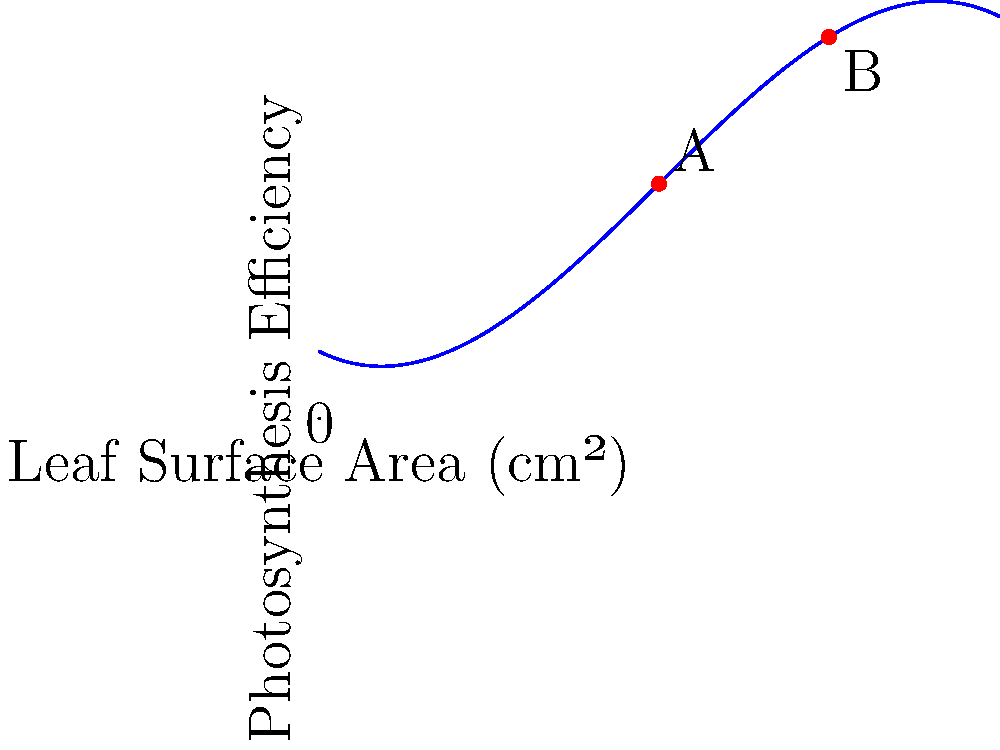The graph shows the relationship between leaf surface area and photosynthesis efficiency for a particular plant species. Point A represents a leaf with a surface area of 10 cm², and point B represents a leaf with a surface area of 15 cm². What is the approximate difference in photosynthesis efficiency between these two leaf sizes? To solve this problem, we need to follow these steps:

1. Identify the y-coordinates (photosynthesis efficiency) for points A and B:
   - Point A (10 cm²): y ≈ 3.5
   - Point B (15 cm²): y ≈ 4.2

2. Calculate the difference in photosynthesis efficiency:
   $\text{Difference} = \text{Efficiency at B} - \text{Efficiency at A}$
   $\text{Difference} \approx 4.2 - 3.5 = 0.7$

The approximate difference in photosynthesis efficiency between the two leaf sizes is 0.7 units.

This result shows that as the leaf surface area increases from 10 cm² to 15 cm², there is a positive change in photosynthesis efficiency. This relationship is typical in many plant species, where larger leaves often have higher photosynthetic capacity up to a certain point, after which efficiency may plateau or decrease due to factors such as self-shading or resource allocation.
Answer: 0.7 